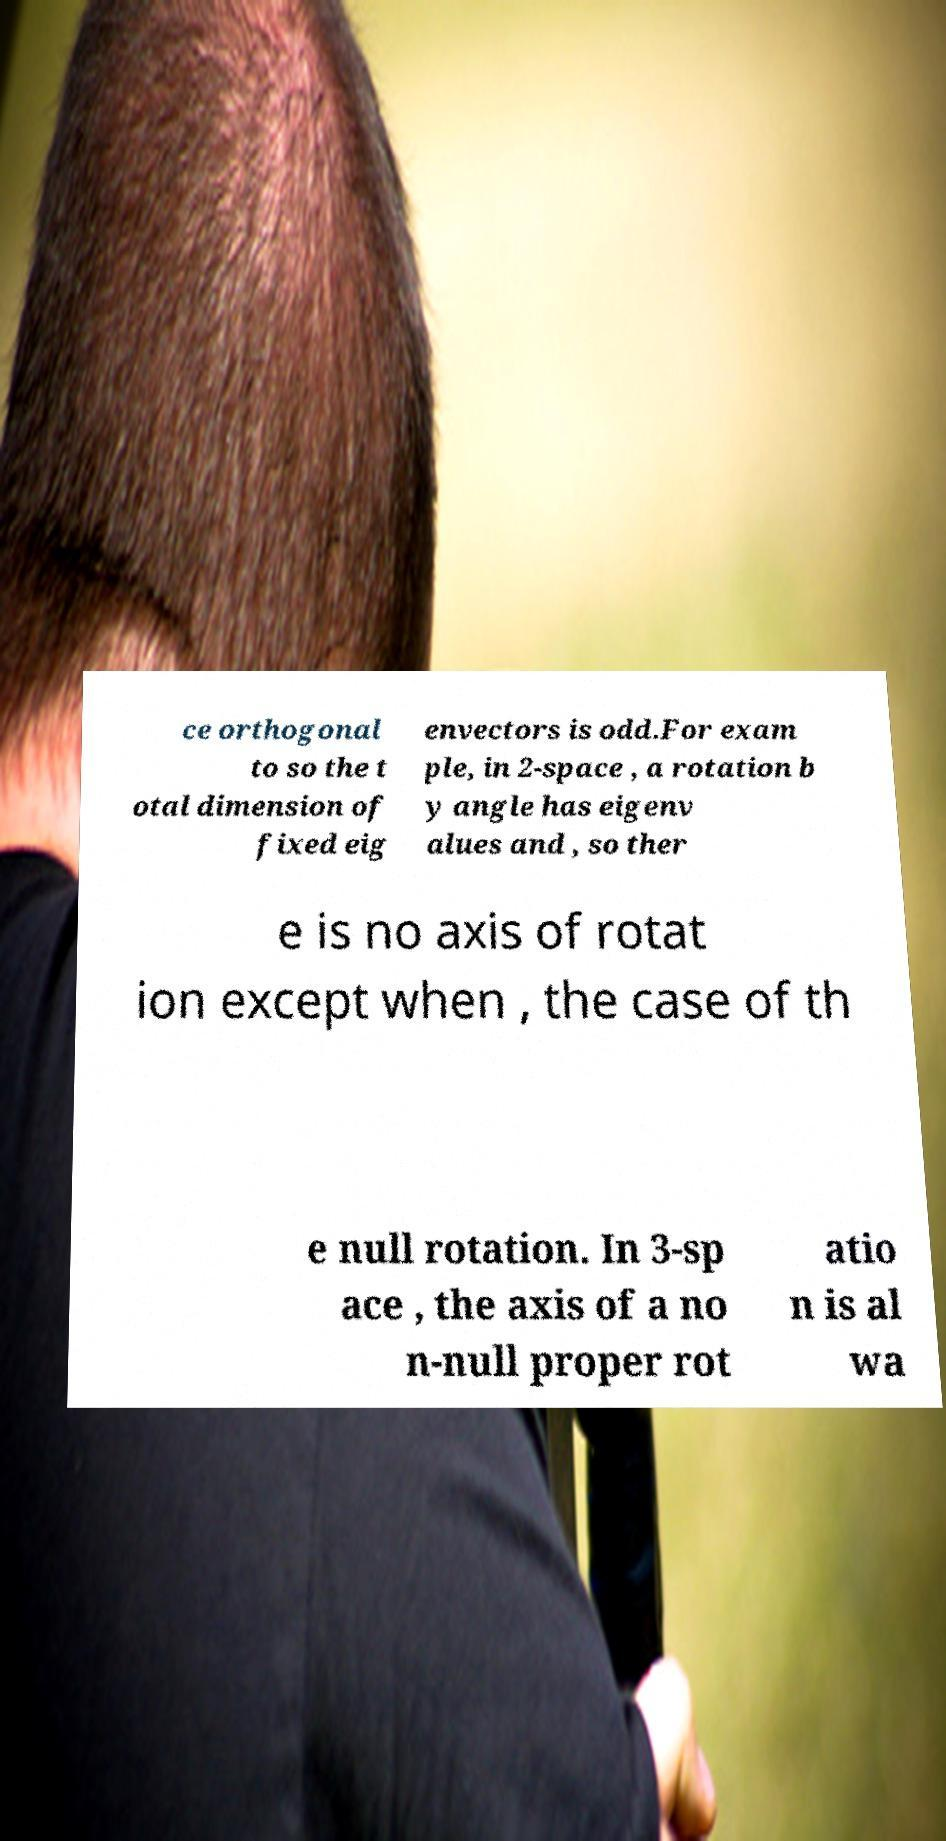For documentation purposes, I need the text within this image transcribed. Could you provide that? ce orthogonal to so the t otal dimension of fixed eig envectors is odd.For exam ple, in 2-space , a rotation b y angle has eigenv alues and , so ther e is no axis of rotat ion except when , the case of th e null rotation. In 3-sp ace , the axis of a no n-null proper rot atio n is al wa 